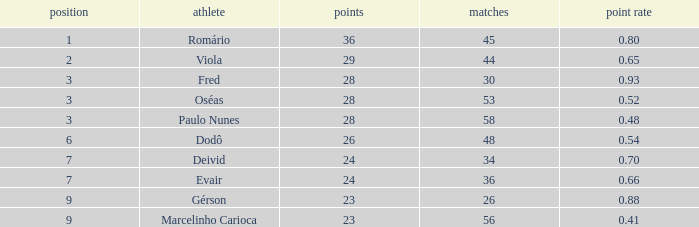What is the number of games with 23 goals and a rank above 9? 0.0. 